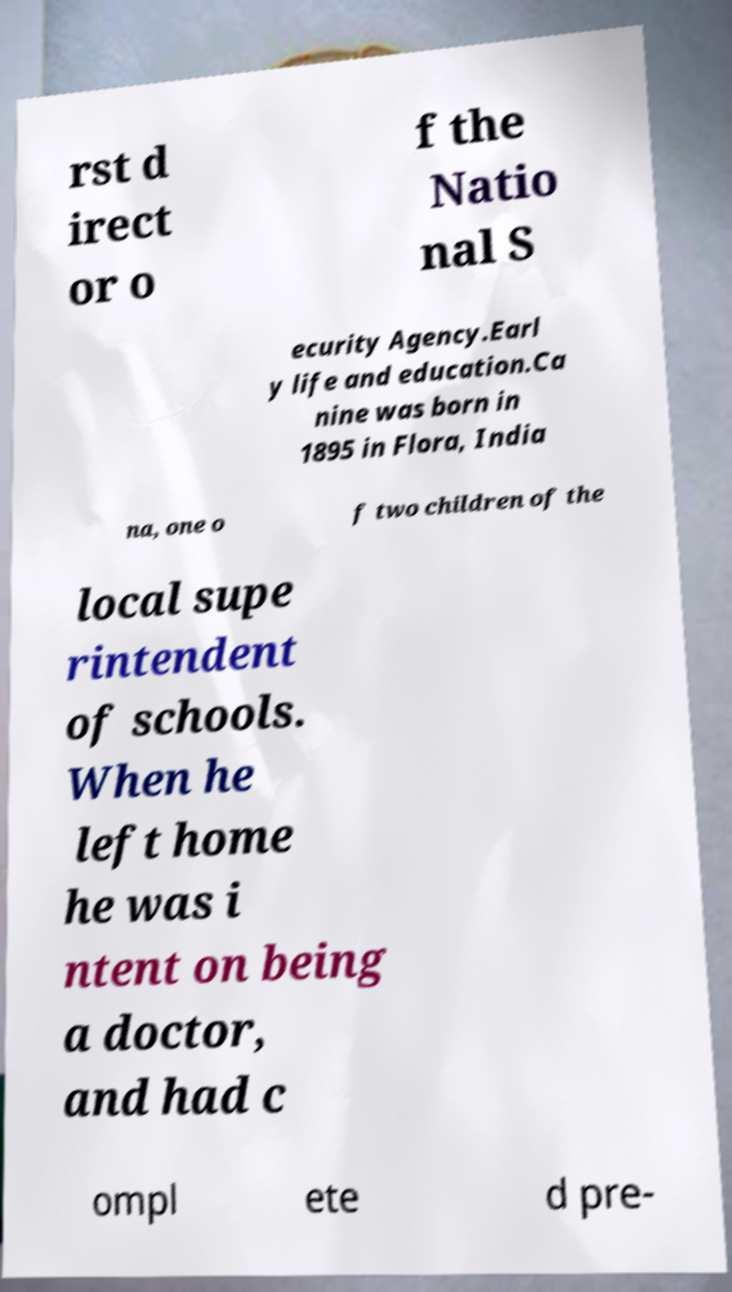What messages or text are displayed in this image? I need them in a readable, typed format. rst d irect or o f the Natio nal S ecurity Agency.Earl y life and education.Ca nine was born in 1895 in Flora, India na, one o f two children of the local supe rintendent of schools. When he left home he was i ntent on being a doctor, and had c ompl ete d pre- 